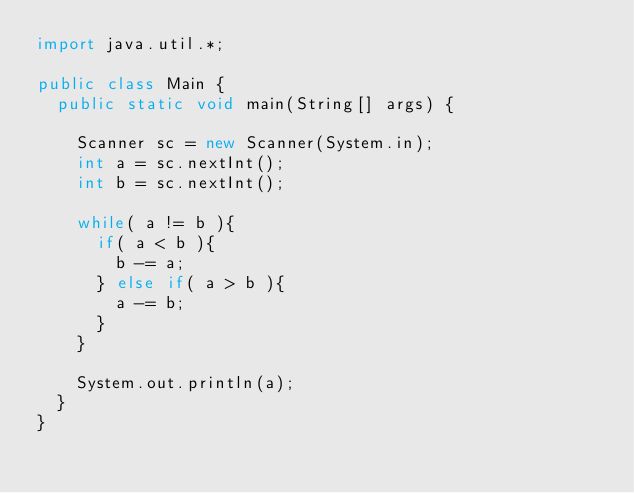Convert code to text. <code><loc_0><loc_0><loc_500><loc_500><_Java_>import java.util.*;

public class Main {
	public static void main(String[] args) {

		Scanner sc = new Scanner(System.in);
		int a = sc.nextInt();
		int b = sc.nextInt();
		
		while( a != b ){
			if( a < b ){
				b -= a;
			} else if( a > b ){
				a -= b;
			}
		}
		
		System.out.println(a);
	}
}</code> 